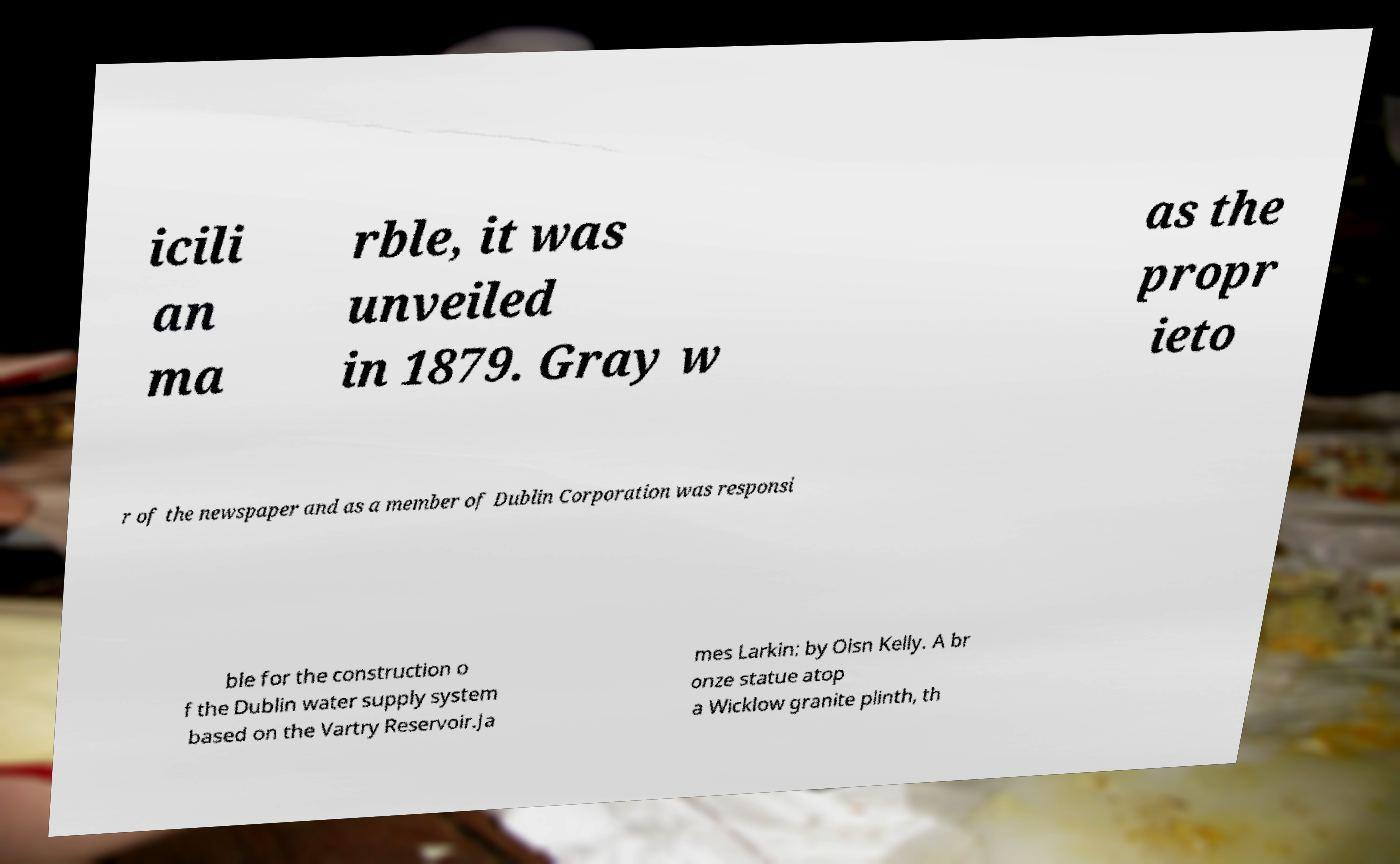For documentation purposes, I need the text within this image transcribed. Could you provide that? icili an ma rble, it was unveiled in 1879. Gray w as the propr ieto r of the newspaper and as a member of Dublin Corporation was responsi ble for the construction o f the Dublin water supply system based on the Vartry Reservoir.Ja mes Larkin: by Oisn Kelly. A br onze statue atop a Wicklow granite plinth, th 